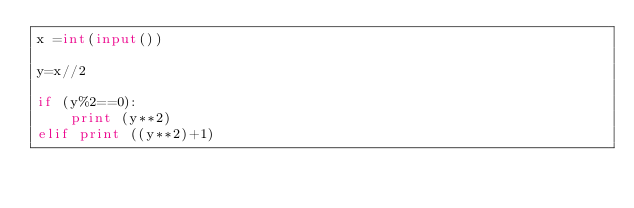<code> <loc_0><loc_0><loc_500><loc_500><_Python_>x =int(input())

y=x//2

if (y%2==0):
    print (y**2)
elif print ((y**2)+1)</code> 